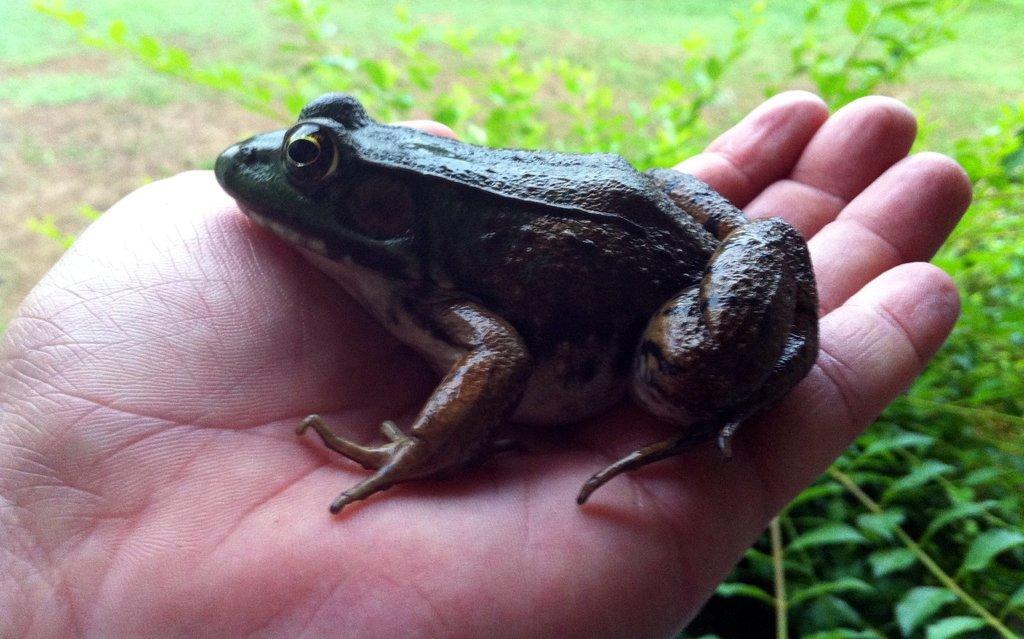Please provide a concise description of this image. In the middle of the image we can see a frog in the hand, and we can find few plants. 